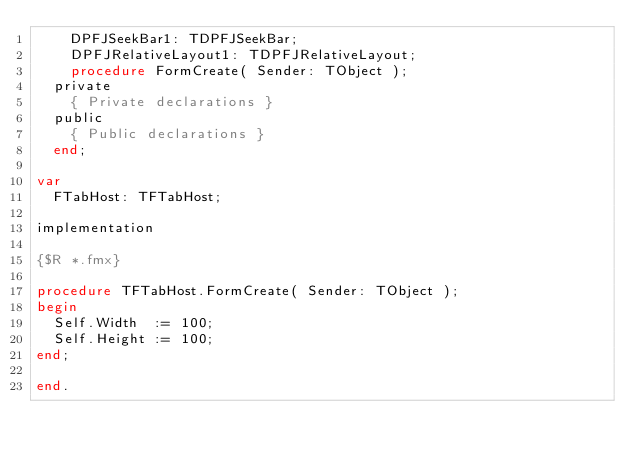Convert code to text. <code><loc_0><loc_0><loc_500><loc_500><_Pascal_>    DPFJSeekBar1: TDPFJSeekBar;
    DPFJRelativeLayout1: TDPFJRelativeLayout;
    procedure FormCreate( Sender: TObject );
  private
    { Private declarations }
  public
    { Public declarations }
  end;

var
  FTabHost: TFTabHost;

implementation

{$R *.fmx}

procedure TFTabHost.FormCreate( Sender: TObject );
begin
  Self.Width  := 100;
  Self.Height := 100;
end;

end.
</code> 